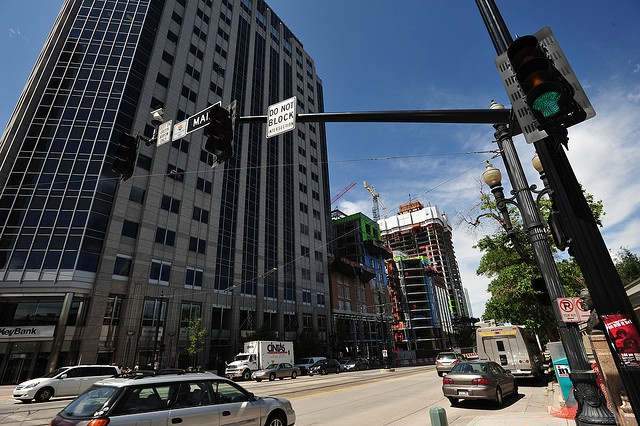Describe the objects in this image and their specific colors. I can see car in gray, black, and darkgray tones, traffic light in gray, black, teal, and darkgreen tones, car in gray, black, maroon, and darkgray tones, car in gray, black, lightgray, and darkgray tones, and truck in gray, darkgray, and black tones in this image. 